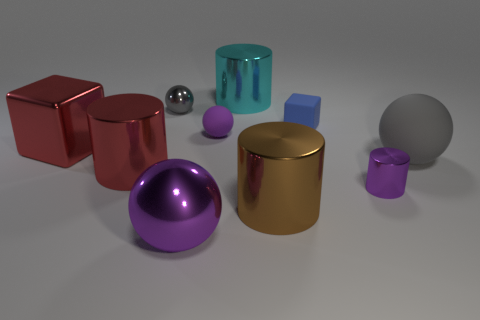There is a gray object to the right of the small purple cylinder; does it have the same shape as the tiny metal object that is behind the purple metal cylinder?
Provide a short and direct response. Yes. What is the size of the gray matte thing that is the same shape as the big purple metal thing?
Provide a succinct answer. Large. What number of purple spheres have the same material as the small cube?
Offer a terse response. 1. What is the material of the big brown cylinder?
Provide a short and direct response. Metal. The small purple object that is to the right of the big cyan metal cylinder behind the large gray object is what shape?
Keep it short and to the point. Cylinder. There is a metal thing to the left of the large red cylinder; what shape is it?
Provide a short and direct response. Cube. What number of objects are the same color as the tiny cylinder?
Ensure brevity in your answer.  2. What color is the tiny cube?
Ensure brevity in your answer.  Blue. There is a gray sphere that is on the left side of the big purple metallic object; how many rubber objects are to the right of it?
Your response must be concise. 3. There is a gray rubber thing; is its size the same as the gray sphere that is behind the large gray rubber object?
Your response must be concise. No. 